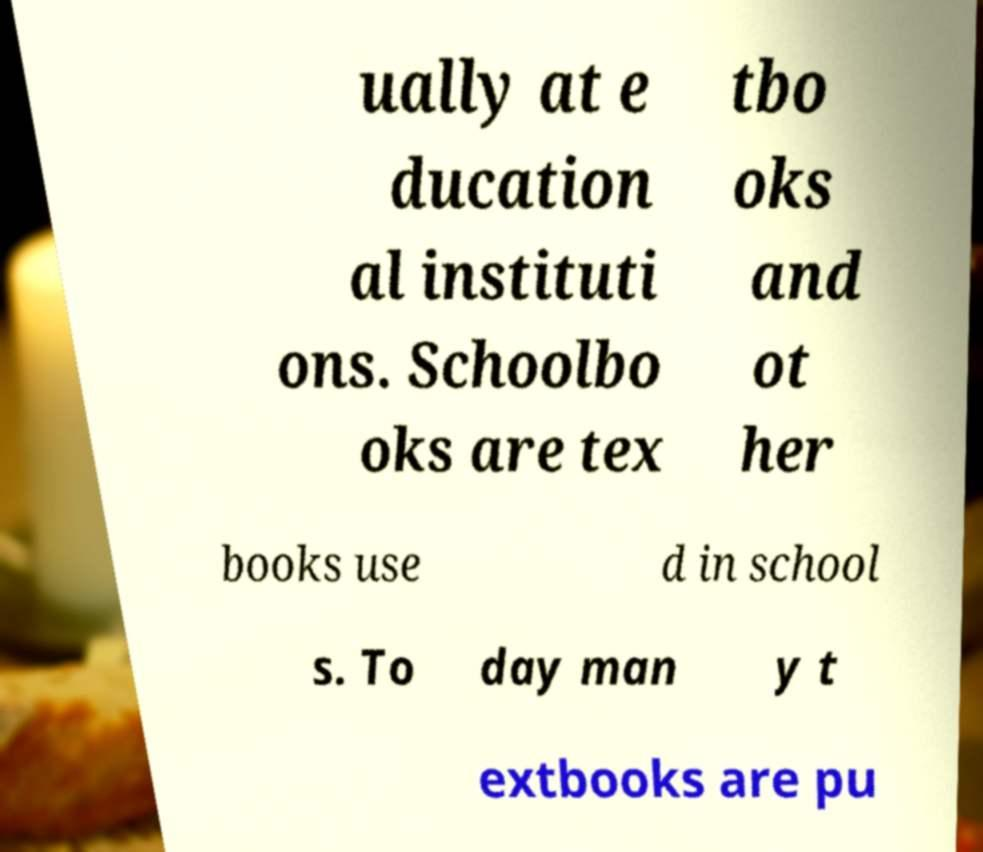Please read and relay the text visible in this image. What does it say? ually at e ducation al instituti ons. Schoolbo oks are tex tbo oks and ot her books use d in school s. To day man y t extbooks are pu 